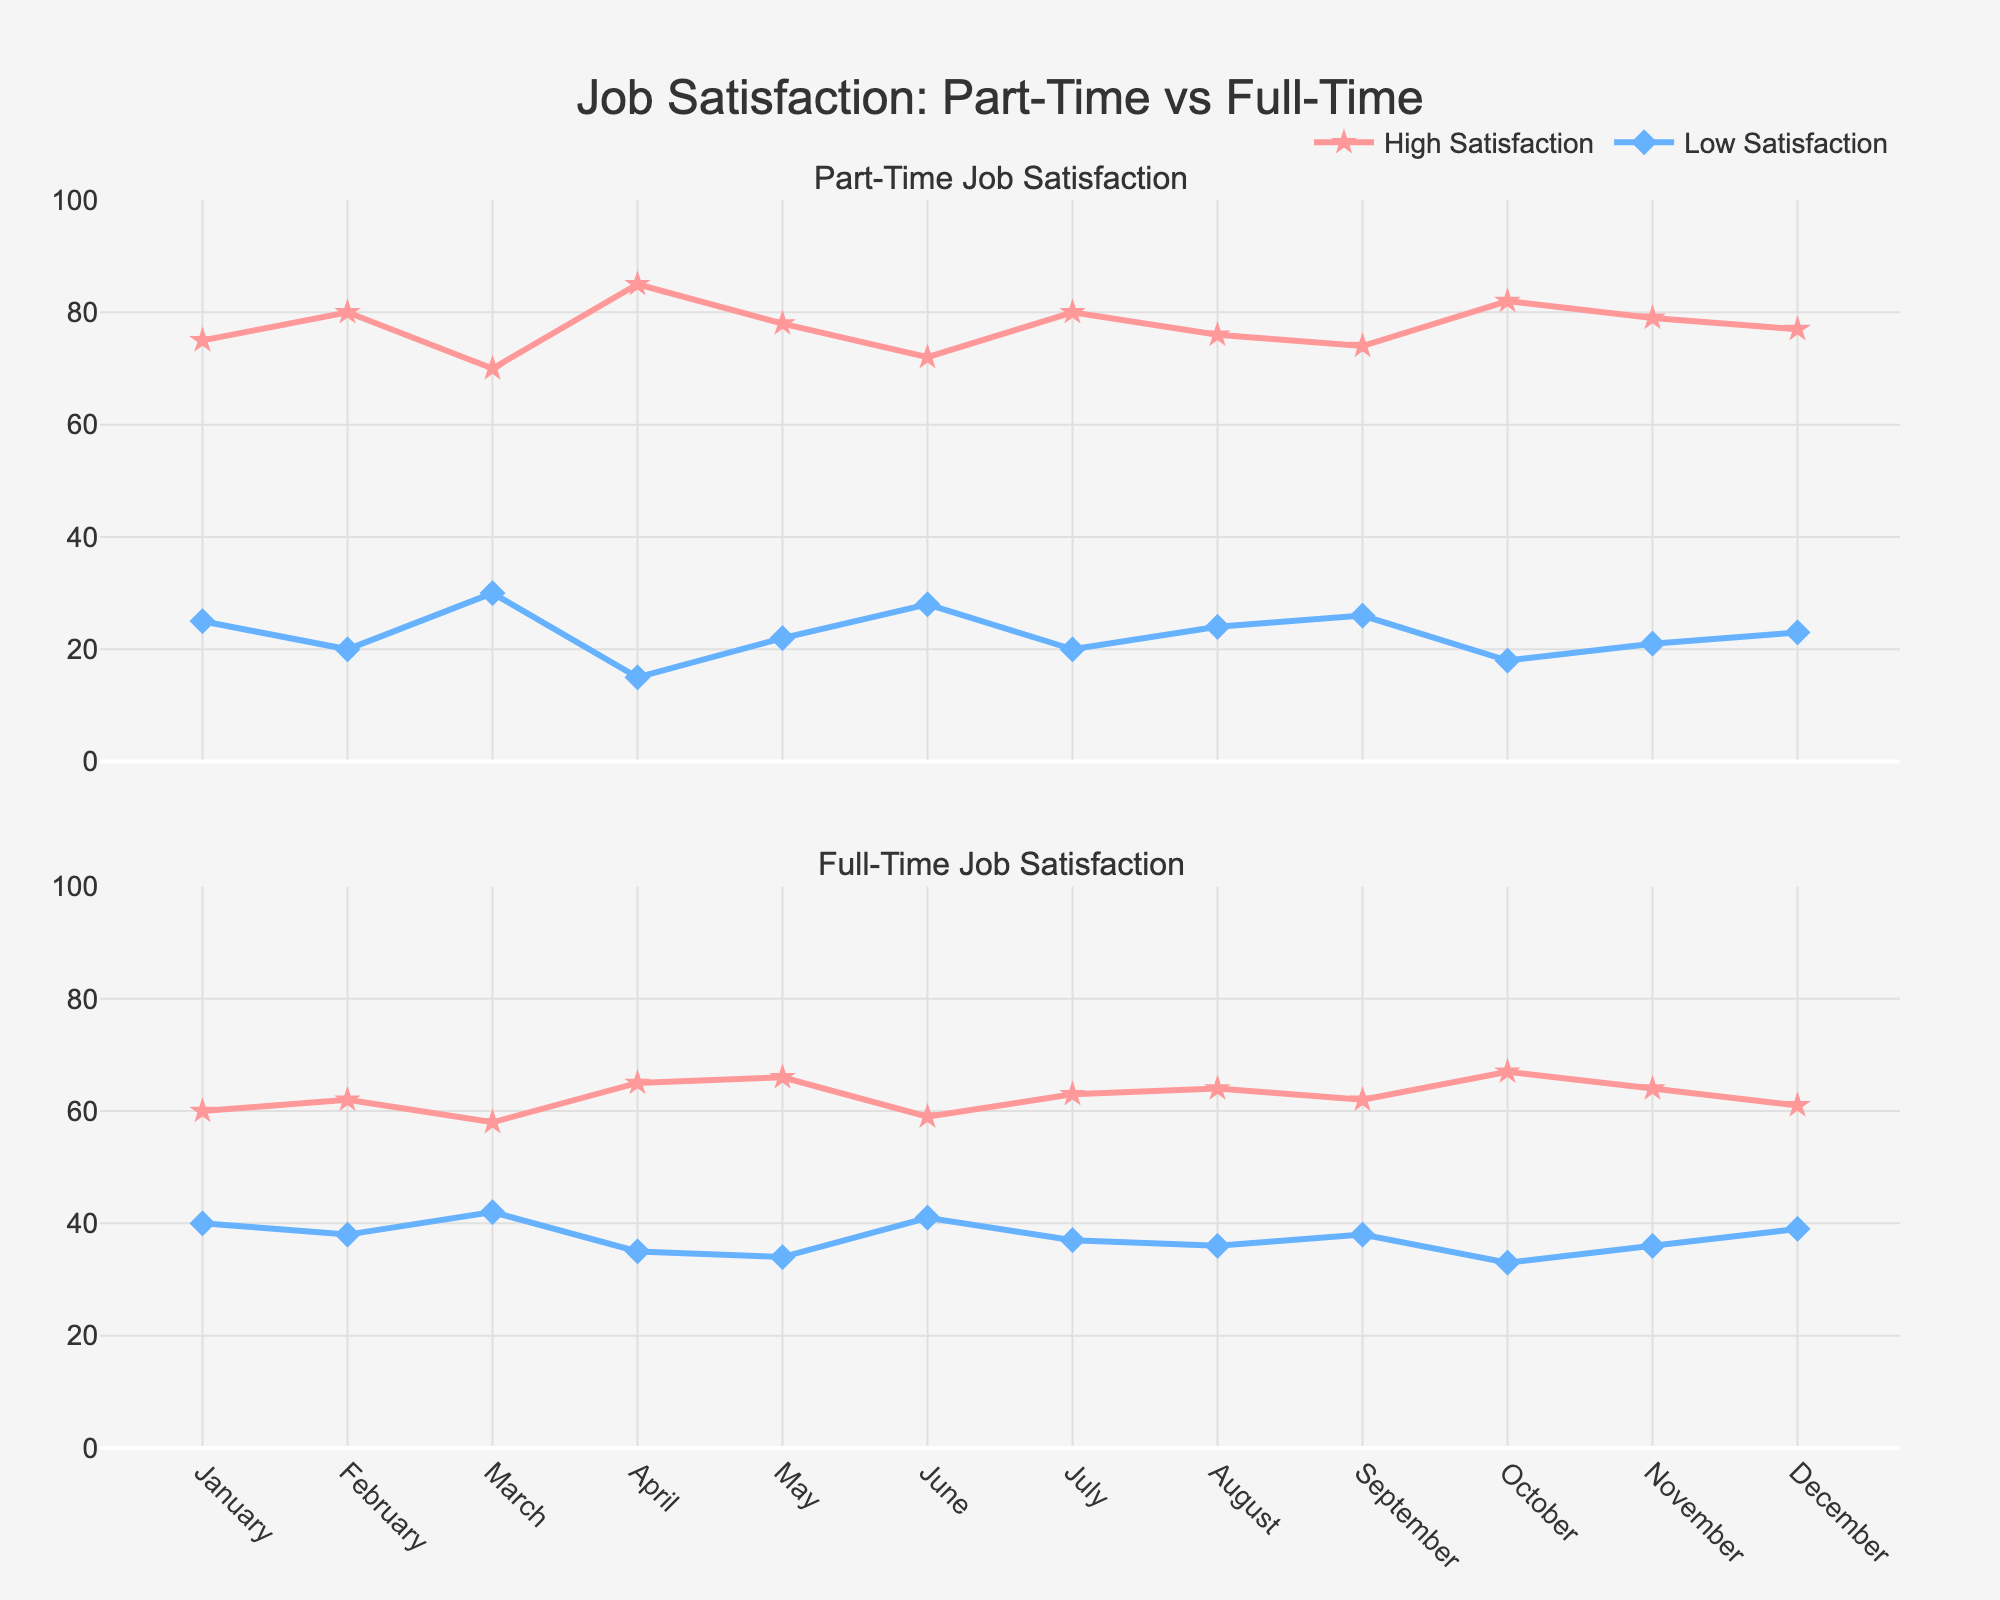How many months are displayed in the figure? The x-axis of the figure shows months from January to December, which indicates a total of 12 data points.
Answer: 12 What colors are used to represent high and low satisfaction in the figure? The lines representing high satisfaction are red, while the lines representing low satisfaction are light blue.
Answer: Red and light blue Which month shows the highest part-time high satisfaction? By observing the top plot for part-time satisfaction, the highest point for high satisfaction appears in April.
Answer: April Are there any months with equal low satisfaction ratings for both part-time and full-time jobs? By comparing the bottom and top plots, we observe that in February, both part-time and full-time positions have equal low satisfaction ratings of 20.
Answer: February What is the average high satisfaction rating for part-time jobs over the year? Add up all the high satisfaction ratings for part-time jobs (75+80+70+85+78+72+80+76+74+82+79+77=948) and divide by 12 (months). The average is 948/12.
Answer: 79 Which type of job generally has higher high satisfaction ratings, part-time or full-time? By comparing the two plots, it is evident that part-time jobs generally have higher high satisfaction ratings throughout the year compared to full-time jobs.
Answer: Part-time Which months show an increase in full-time high satisfaction from the previous month? Observing the line in the bottom plot, increases in full-time high satisfaction occur from January to February, February to April, April to May, July to August, August to October, and October to November.
Answer: February, April, May, August, October, November In which month do part-time jobs show the highest low satisfaction? The highest point for part-time low satisfaction in the top plot occurs in March, having a value of 30.
Answer: March What is the trend of part-time high satisfaction ratings from January to June? Observing the top plot, part-time high satisfaction ratings rise from January to February, drop in March, rise to the highest in April, drop in May, and decrease further in June, showing a fluctuating trend.
Answer: Fluctuating By how much do full-time high satisfaction ratings increase from March to April? In March, the full-time high satisfaction rating is 58, and in April, it is 65. The increase is calculated as 65 - 58.
Answer: 7 